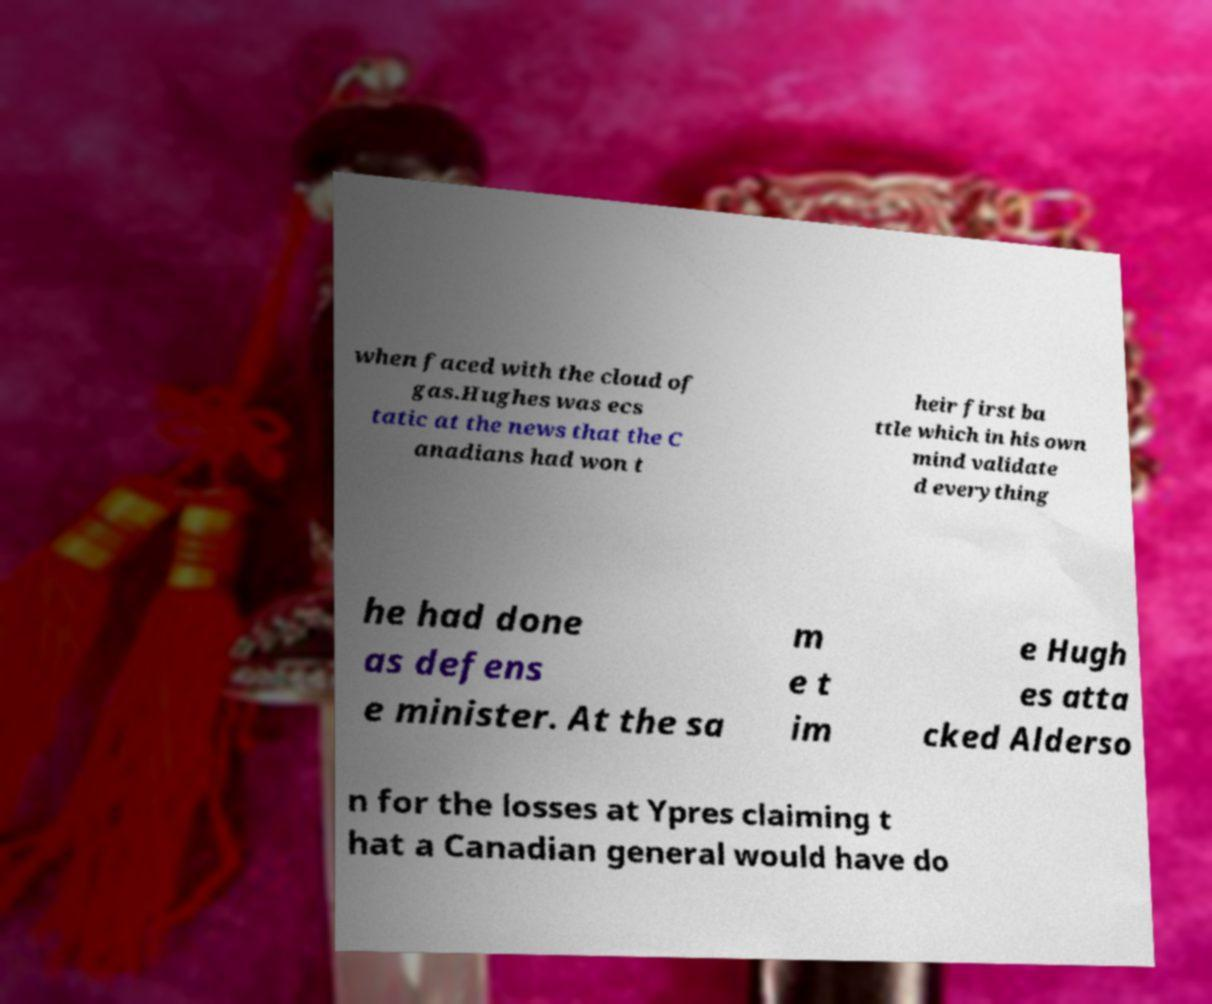What messages or text are displayed in this image? I need them in a readable, typed format. when faced with the cloud of gas.Hughes was ecs tatic at the news that the C anadians had won t heir first ba ttle which in his own mind validate d everything he had done as defens e minister. At the sa m e t im e Hugh es atta cked Alderso n for the losses at Ypres claiming t hat a Canadian general would have do 